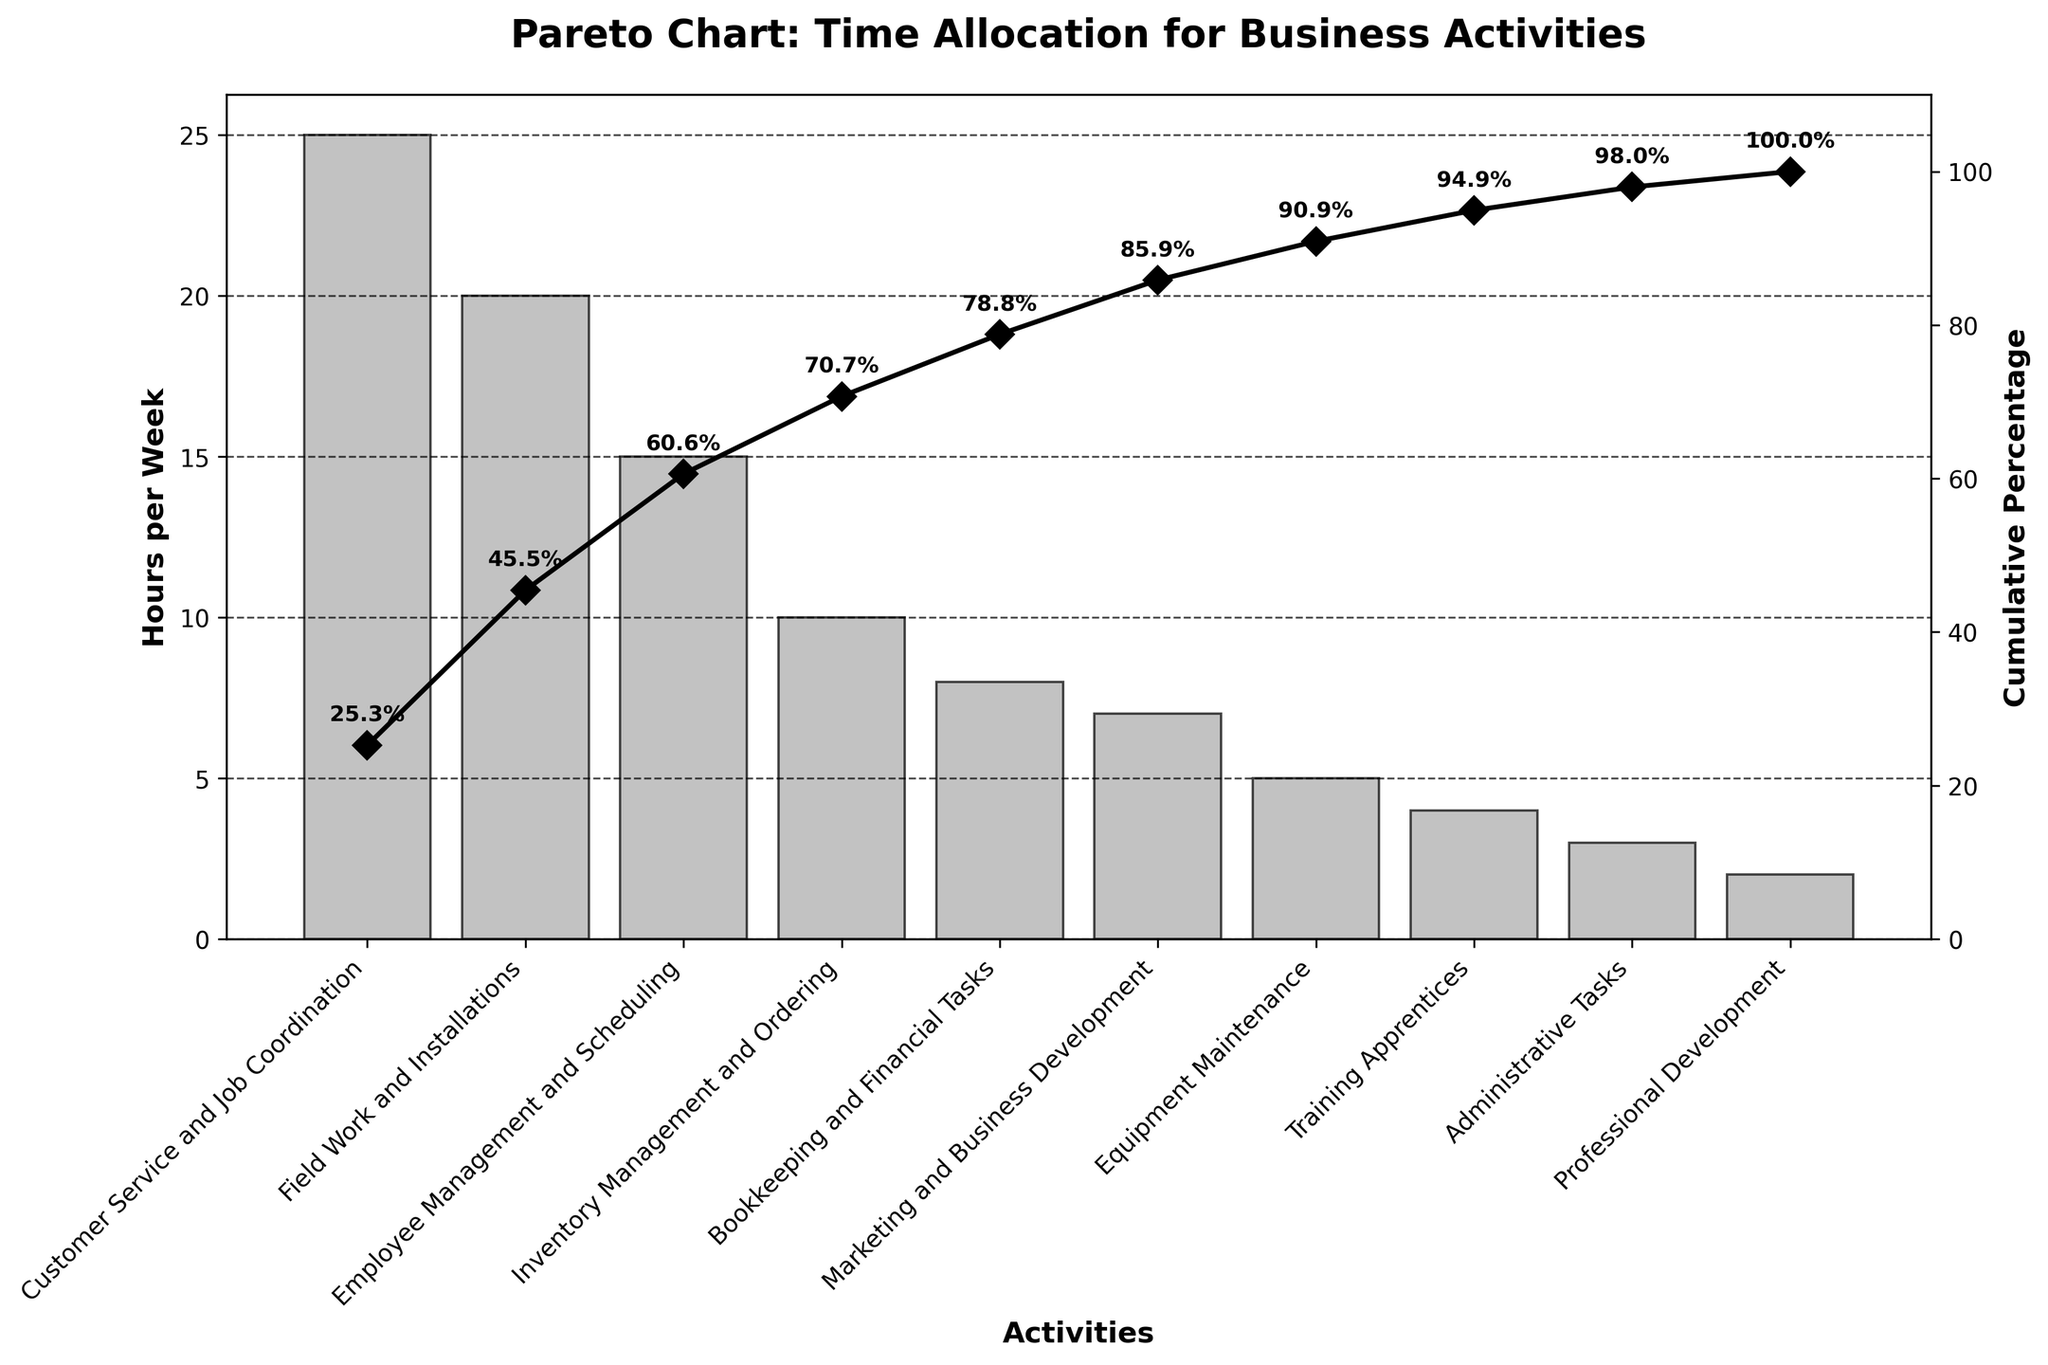What's the title of the chart? The title is located at the top of the chart and provides a summary of what the chart represents.
Answer: Pareto Chart: Time Allocation for Business Activities Which activity consumes the most time per week? The activity that has the tallest bar on the bar plot represents the one that consumes the most time per week.
Answer: Customer Service and Job Coordination What is the cumulative percentage for Inventory Management and Ordering? The cumulative percentage curve shows the accumulation of time allocation percentages. Look for the Inventory Management and Ordering point on this curve and check the corresponding percentage label.
Answer: 70.0% Which activity has the lowest time allocation? The activity with the shortest bar on the bar plot represents the one with the lowest time allocation per week.
Answer: Professional Development What is the total weekly time allocation for the top three activities? Sum the hours per week of the top three activities which are Customer Service and Job Coordination, Field Work and Installations, and Employee Management and Scheduling: 25 + 20 + 15.
Answer: 60 hours How many hours are allocated weekly to Training Apprentices? Find the bar that corresponds to Training Apprentices and read the height of the bar.
Answer: 4 hours What is the cumulative percentage for the Employee Management and Scheduling activity? Locate Employee Management and Scheduling on the cumulative percentage curve and check the percentage label.
Answer: 70.0% How does the time allocation for Bookkeeping and Financial Tasks compare to Marketing and Business Development? Compare the height of the bars for Bookkeeping and Financial Tasks and Marketing and Business Development to see which is taller.
Answer: Bookkeeping and Financial Tasks has more time allocated What cumulative percentage is reached after allocating time to the first five activities? Identify the fifth activity in order (Inventory Management and Ordering) and check the cumulative percentage label at that point on the curve.
Answer: 80.0% What is the cumulative percentage after including Training Apprentices? Find Training Apprentices on the cumulative percentage curve and read the corresponding value.
Answer: 98.0% 